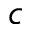Convert formula to latex. <formula><loc_0><loc_0><loc_500><loc_500>c</formula> 